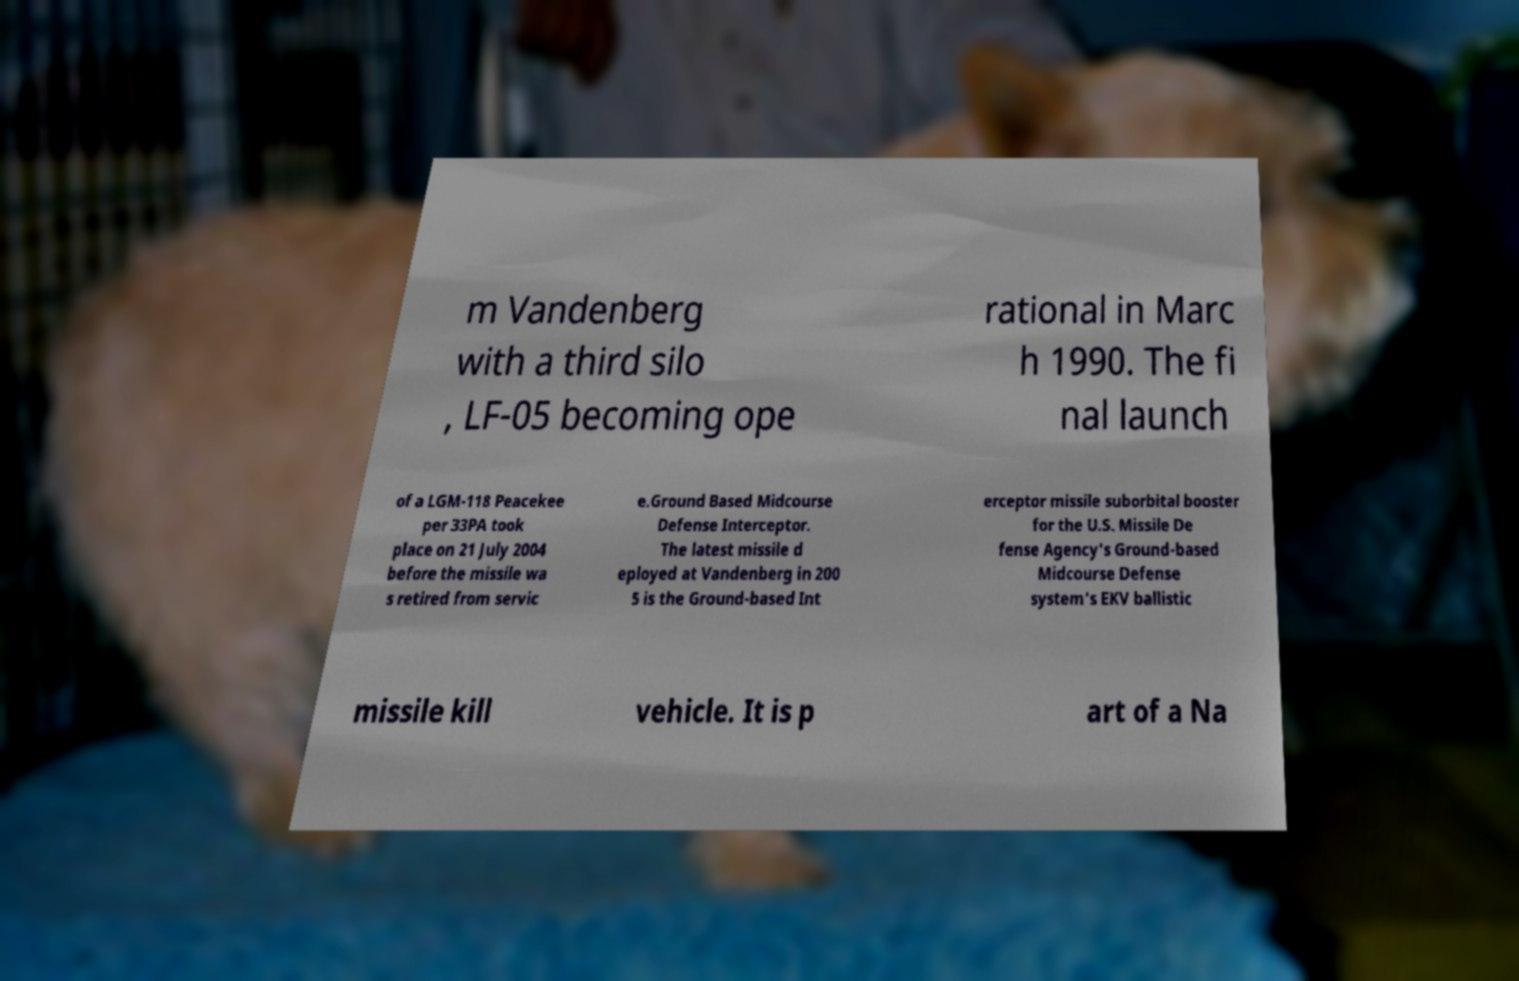I need the written content from this picture converted into text. Can you do that? m Vandenberg with a third silo , LF-05 becoming ope rational in Marc h 1990. The fi nal launch of a LGM-118 Peacekee per 33PA took place on 21 July 2004 before the missile wa s retired from servic e.Ground Based Midcourse Defense Interceptor. The latest missile d eployed at Vandenberg in 200 5 is the Ground-based Int erceptor missile suborbital booster for the U.S. Missile De fense Agency's Ground-based Midcourse Defense system's EKV ballistic missile kill vehicle. It is p art of a Na 